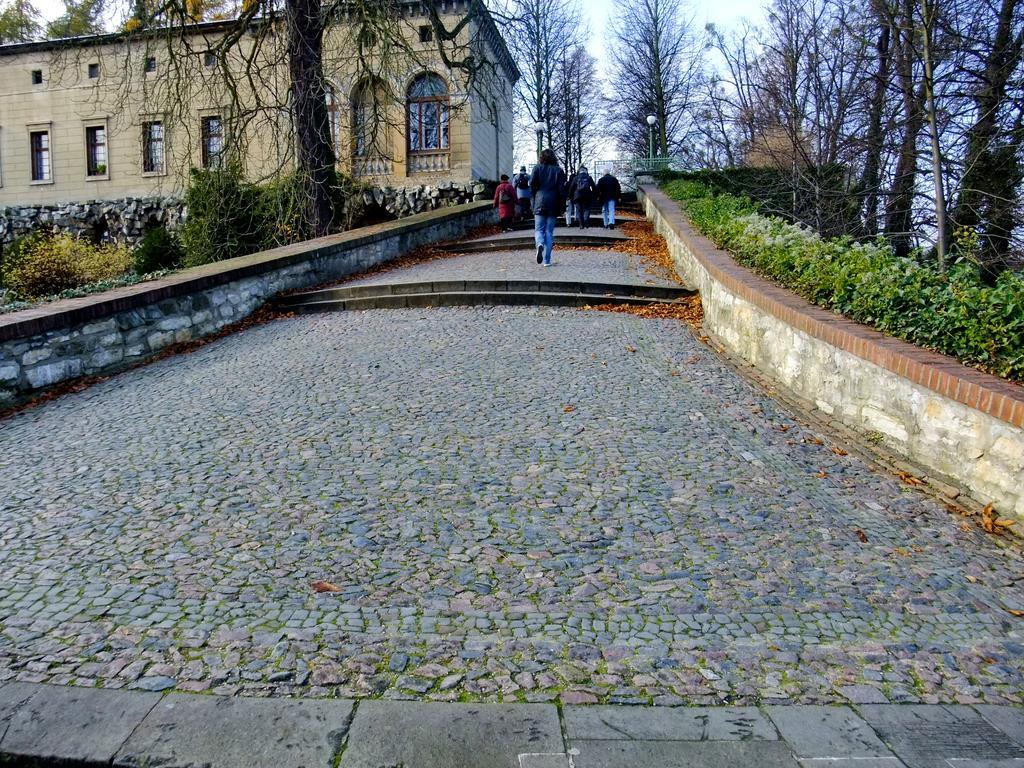Could you give a brief overview of what you see in this image? In this picture I can see there is a walkway, there are few people walking and there are dry leaves, there are plants at right and left sides. There is a building on the left side, with windows and there are trees and the sky is clear. 